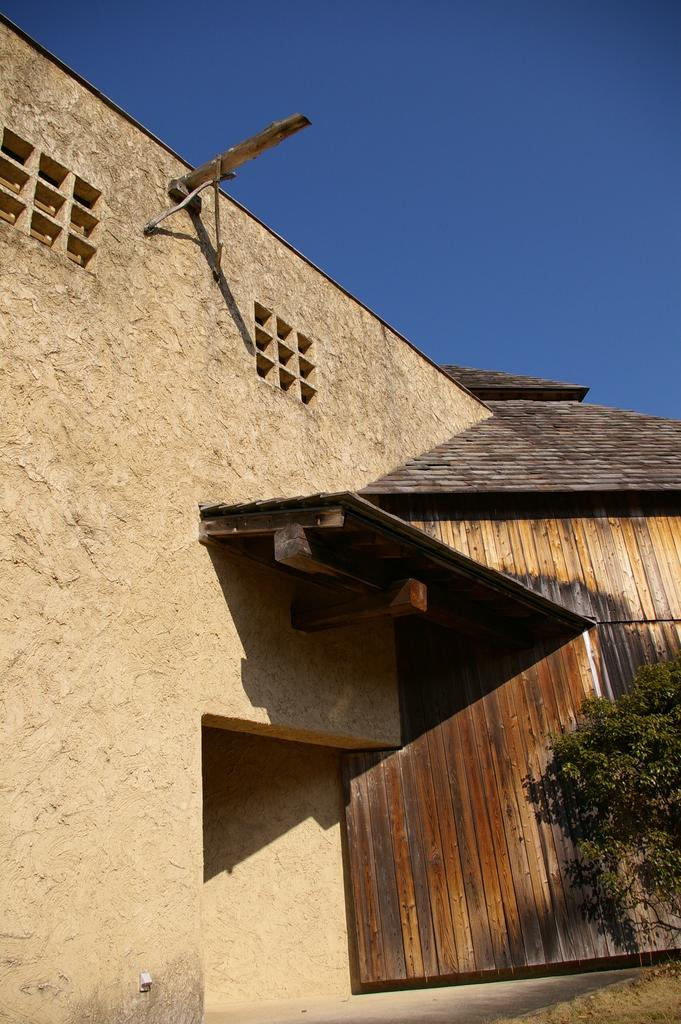What type of structure is visible in the image? There is a building in the image. What other object can be seen in the image besides the building? There is a wooden object in the image. Where is the tree located in the image? The tree is in the right corner of the image. What color is the sky in the image? The sky is blue in color. What type of popcorn is being served by the company during their journey in the image? There is no popcorn, company, or journey present in the image. 